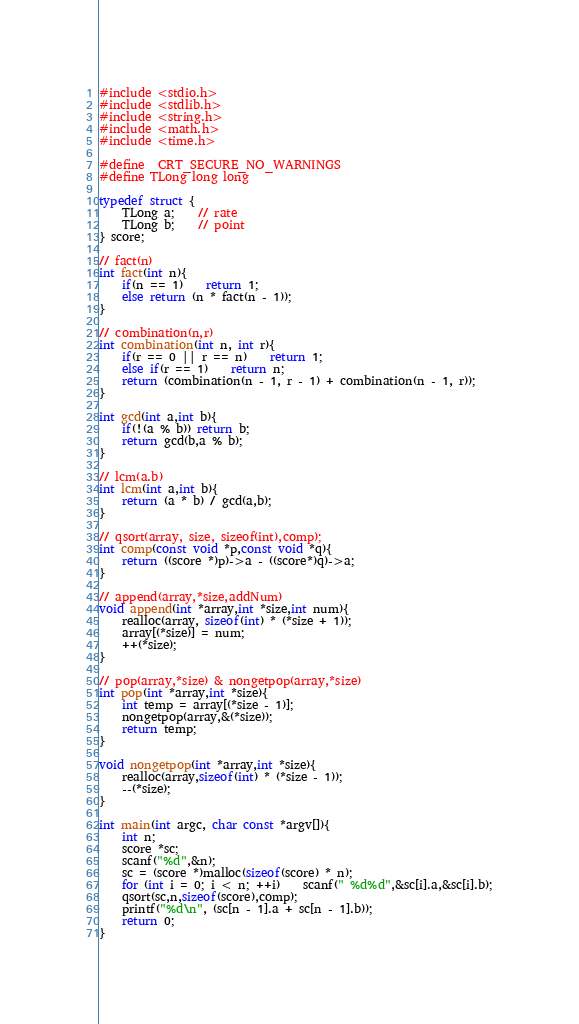Convert code to text. <code><loc_0><loc_0><loc_500><loc_500><_C_>#include <stdio.h>
#include <stdlib.h>
#include <string.h>
#include <math.h>
#include <time.h>

#define _CRT_SECURE_NO_WARNINGS
#define TLong long long 

typedef struct {
	TLong a;	// rate
	TLong b;	// point
} score;

// fact(n)
int fact(int n){
	if(n == 1)	return 1;
	else return (n * fact(n - 1));
}

// combination(n,r)
int combination(int n, int r){
	if(r == 0 || r == n)	return 1;
	else if(r == 1)	return n;
	return (combination(n - 1, r - 1) + combination(n - 1, r));
}

int gcd(int a,int b){
	if(!(a % b)) return b;
	return gcd(b,a % b);
}

// lcm(a.b)
int lcm(int a,int b){
	return (a * b) / gcd(a,b);
}

// qsort(array, size, sizeof(int),comp);
int comp(const void *p,const void *q){
    return ((score *)p)->a - ((score*)q)->a;
}

// append(array,*size,addNum)
void append(int *array,int *size,int num){
	realloc(array, sizeof(int) * (*size + 1));
	array[(*size)] = num;
	++(*size);
}

// pop(array,*size) & nongetpop(array,*size)
int pop(int *array,int *size){
	int temp = array[(*size - 1)];
	nongetpop(array,&(*size));
	return temp;
}

void nongetpop(int *array,int *size){
	realloc(array,sizeof(int) * (*size - 1));
	--(*size);
}

int main(int argc, char const *argv[]){
	int n;
	score *sc;
	scanf("%d",&n);
	sc = (score *)malloc(sizeof(score) * n);
	for (int i = 0; i < n; ++i)	scanf(" %d%d",&sc[i].a,&sc[i].b);
	qsort(sc,n,sizeof(score),comp);
	printf("%d\n", (sc[n - 1].a + sc[n - 1].b));
	return 0;
}
</code> 